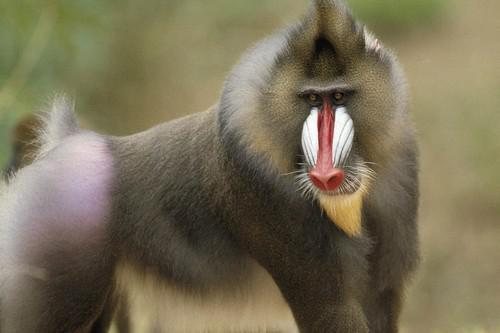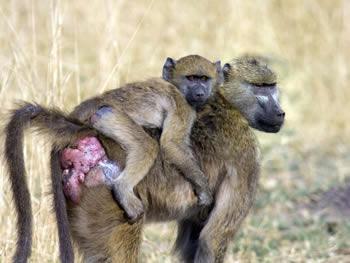The first image is the image on the left, the second image is the image on the right. For the images displayed, is the sentence "An image shows a baboon standing on all fours with part of its bulbous pink hairless rear showing." factually correct? Answer yes or no. Yes. The first image is the image on the left, the second image is the image on the right. For the images displayed, is the sentence "The primate in the image on the left has greyish whitish hair." factually correct? Answer yes or no. No. 